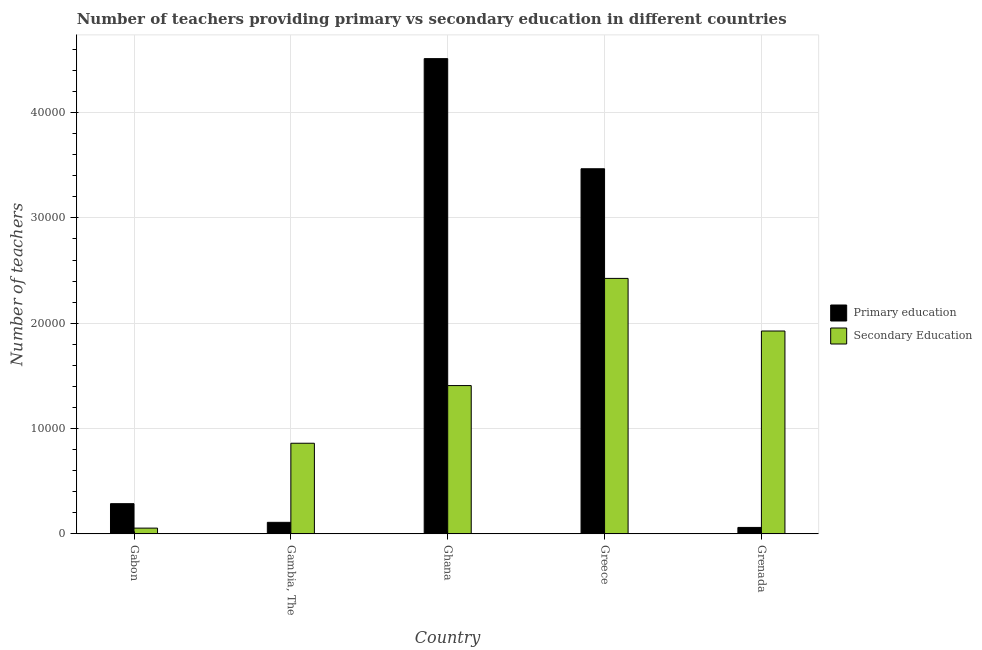How many different coloured bars are there?
Your response must be concise. 2. How many groups of bars are there?
Your answer should be compact. 5. Are the number of bars per tick equal to the number of legend labels?
Give a very brief answer. Yes. How many bars are there on the 2nd tick from the right?
Provide a succinct answer. 2. What is the label of the 1st group of bars from the left?
Provide a short and direct response. Gabon. In how many cases, is the number of bars for a given country not equal to the number of legend labels?
Ensure brevity in your answer.  0. What is the number of secondary teachers in Grenada?
Make the answer very short. 1.93e+04. Across all countries, what is the maximum number of primary teachers?
Ensure brevity in your answer.  4.51e+04. Across all countries, what is the minimum number of primary teachers?
Offer a very short reply. 610. In which country was the number of secondary teachers minimum?
Keep it short and to the point. Gabon. What is the total number of primary teachers in the graph?
Your response must be concise. 8.44e+04. What is the difference between the number of secondary teachers in Gabon and that in Grenada?
Make the answer very short. -1.87e+04. What is the difference between the number of secondary teachers in Gambia, The and the number of primary teachers in Ghana?
Your answer should be very brief. -3.65e+04. What is the average number of primary teachers per country?
Make the answer very short. 1.69e+04. What is the difference between the number of primary teachers and number of secondary teachers in Gabon?
Offer a terse response. 2321. In how many countries, is the number of primary teachers greater than 32000 ?
Your response must be concise. 2. What is the ratio of the number of secondary teachers in Gambia, The to that in Greece?
Offer a very short reply. 0.35. What is the difference between the highest and the second highest number of secondary teachers?
Your answer should be very brief. 4995. What is the difference between the highest and the lowest number of primary teachers?
Provide a short and direct response. 4.45e+04. In how many countries, is the number of secondary teachers greater than the average number of secondary teachers taken over all countries?
Give a very brief answer. 3. What does the 1st bar from the right in Ghana represents?
Keep it short and to the point. Secondary Education. How many countries are there in the graph?
Your answer should be compact. 5. What is the difference between two consecutive major ticks on the Y-axis?
Keep it short and to the point. 10000. Are the values on the major ticks of Y-axis written in scientific E-notation?
Offer a very short reply. No. Where does the legend appear in the graph?
Give a very brief answer. Center right. How are the legend labels stacked?
Offer a terse response. Vertical. What is the title of the graph?
Keep it short and to the point. Number of teachers providing primary vs secondary education in different countries. What is the label or title of the Y-axis?
Ensure brevity in your answer.  Number of teachers. What is the Number of teachers in Primary education in Gabon?
Make the answer very short. 2866. What is the Number of teachers in Secondary Education in Gabon?
Offer a very short reply. 545. What is the Number of teachers in Primary education in Gambia, The?
Your answer should be compact. 1094. What is the Number of teachers in Secondary Education in Gambia, The?
Keep it short and to the point. 8604. What is the Number of teachers in Primary education in Ghana?
Your answer should be compact. 4.51e+04. What is the Number of teachers of Secondary Education in Ghana?
Provide a succinct answer. 1.41e+04. What is the Number of teachers of Primary education in Greece?
Offer a terse response. 3.47e+04. What is the Number of teachers of Secondary Education in Greece?
Give a very brief answer. 2.43e+04. What is the Number of teachers in Primary education in Grenada?
Offer a terse response. 610. What is the Number of teachers of Secondary Education in Grenada?
Make the answer very short. 1.93e+04. Across all countries, what is the maximum Number of teachers in Primary education?
Offer a terse response. 4.51e+04. Across all countries, what is the maximum Number of teachers in Secondary Education?
Provide a succinct answer. 2.43e+04. Across all countries, what is the minimum Number of teachers in Primary education?
Give a very brief answer. 610. Across all countries, what is the minimum Number of teachers of Secondary Education?
Your answer should be very brief. 545. What is the total Number of teachers in Primary education in the graph?
Ensure brevity in your answer.  8.44e+04. What is the total Number of teachers of Secondary Education in the graph?
Your answer should be very brief. 6.67e+04. What is the difference between the Number of teachers in Primary education in Gabon and that in Gambia, The?
Make the answer very short. 1772. What is the difference between the Number of teachers in Secondary Education in Gabon and that in Gambia, The?
Provide a succinct answer. -8059. What is the difference between the Number of teachers of Primary education in Gabon and that in Ghana?
Keep it short and to the point. -4.23e+04. What is the difference between the Number of teachers in Secondary Education in Gabon and that in Ghana?
Keep it short and to the point. -1.35e+04. What is the difference between the Number of teachers in Primary education in Gabon and that in Greece?
Provide a short and direct response. -3.18e+04. What is the difference between the Number of teachers of Secondary Education in Gabon and that in Greece?
Ensure brevity in your answer.  -2.37e+04. What is the difference between the Number of teachers of Primary education in Gabon and that in Grenada?
Make the answer very short. 2256. What is the difference between the Number of teachers in Secondary Education in Gabon and that in Grenada?
Keep it short and to the point. -1.87e+04. What is the difference between the Number of teachers of Primary education in Gambia, The and that in Ghana?
Offer a terse response. -4.40e+04. What is the difference between the Number of teachers in Secondary Education in Gambia, The and that in Ghana?
Your response must be concise. -5475. What is the difference between the Number of teachers of Primary education in Gambia, The and that in Greece?
Give a very brief answer. -3.36e+04. What is the difference between the Number of teachers in Secondary Education in Gambia, The and that in Greece?
Your answer should be very brief. -1.57e+04. What is the difference between the Number of teachers of Primary education in Gambia, The and that in Grenada?
Offer a terse response. 484. What is the difference between the Number of teachers in Secondary Education in Gambia, The and that in Grenada?
Offer a terse response. -1.07e+04. What is the difference between the Number of teachers of Primary education in Ghana and that in Greece?
Give a very brief answer. 1.05e+04. What is the difference between the Number of teachers in Secondary Education in Ghana and that in Greece?
Keep it short and to the point. -1.02e+04. What is the difference between the Number of teachers in Primary education in Ghana and that in Grenada?
Ensure brevity in your answer.  4.45e+04. What is the difference between the Number of teachers of Secondary Education in Ghana and that in Grenada?
Your response must be concise. -5181. What is the difference between the Number of teachers in Primary education in Greece and that in Grenada?
Ensure brevity in your answer.  3.41e+04. What is the difference between the Number of teachers of Secondary Education in Greece and that in Grenada?
Offer a terse response. 4995. What is the difference between the Number of teachers of Primary education in Gabon and the Number of teachers of Secondary Education in Gambia, The?
Offer a very short reply. -5738. What is the difference between the Number of teachers of Primary education in Gabon and the Number of teachers of Secondary Education in Ghana?
Give a very brief answer. -1.12e+04. What is the difference between the Number of teachers of Primary education in Gabon and the Number of teachers of Secondary Education in Greece?
Provide a short and direct response. -2.14e+04. What is the difference between the Number of teachers in Primary education in Gabon and the Number of teachers in Secondary Education in Grenada?
Offer a very short reply. -1.64e+04. What is the difference between the Number of teachers in Primary education in Gambia, The and the Number of teachers in Secondary Education in Ghana?
Your response must be concise. -1.30e+04. What is the difference between the Number of teachers in Primary education in Gambia, The and the Number of teachers in Secondary Education in Greece?
Your answer should be compact. -2.32e+04. What is the difference between the Number of teachers in Primary education in Gambia, The and the Number of teachers in Secondary Education in Grenada?
Give a very brief answer. -1.82e+04. What is the difference between the Number of teachers of Primary education in Ghana and the Number of teachers of Secondary Education in Greece?
Provide a short and direct response. 2.09e+04. What is the difference between the Number of teachers in Primary education in Ghana and the Number of teachers in Secondary Education in Grenada?
Provide a succinct answer. 2.59e+04. What is the difference between the Number of teachers in Primary education in Greece and the Number of teachers in Secondary Education in Grenada?
Your answer should be compact. 1.54e+04. What is the average Number of teachers in Primary education per country?
Keep it short and to the point. 1.69e+04. What is the average Number of teachers in Secondary Education per country?
Ensure brevity in your answer.  1.33e+04. What is the difference between the Number of teachers of Primary education and Number of teachers of Secondary Education in Gabon?
Offer a very short reply. 2321. What is the difference between the Number of teachers in Primary education and Number of teachers in Secondary Education in Gambia, The?
Your response must be concise. -7510. What is the difference between the Number of teachers of Primary education and Number of teachers of Secondary Education in Ghana?
Offer a terse response. 3.10e+04. What is the difference between the Number of teachers of Primary education and Number of teachers of Secondary Education in Greece?
Your answer should be very brief. 1.04e+04. What is the difference between the Number of teachers of Primary education and Number of teachers of Secondary Education in Grenada?
Make the answer very short. -1.86e+04. What is the ratio of the Number of teachers of Primary education in Gabon to that in Gambia, The?
Your response must be concise. 2.62. What is the ratio of the Number of teachers of Secondary Education in Gabon to that in Gambia, The?
Make the answer very short. 0.06. What is the ratio of the Number of teachers in Primary education in Gabon to that in Ghana?
Give a very brief answer. 0.06. What is the ratio of the Number of teachers in Secondary Education in Gabon to that in Ghana?
Your response must be concise. 0.04. What is the ratio of the Number of teachers in Primary education in Gabon to that in Greece?
Your response must be concise. 0.08. What is the ratio of the Number of teachers in Secondary Education in Gabon to that in Greece?
Provide a succinct answer. 0.02. What is the ratio of the Number of teachers of Primary education in Gabon to that in Grenada?
Give a very brief answer. 4.7. What is the ratio of the Number of teachers of Secondary Education in Gabon to that in Grenada?
Ensure brevity in your answer.  0.03. What is the ratio of the Number of teachers in Primary education in Gambia, The to that in Ghana?
Ensure brevity in your answer.  0.02. What is the ratio of the Number of teachers of Secondary Education in Gambia, The to that in Ghana?
Your answer should be compact. 0.61. What is the ratio of the Number of teachers in Primary education in Gambia, The to that in Greece?
Your answer should be very brief. 0.03. What is the ratio of the Number of teachers of Secondary Education in Gambia, The to that in Greece?
Provide a succinct answer. 0.35. What is the ratio of the Number of teachers of Primary education in Gambia, The to that in Grenada?
Keep it short and to the point. 1.79. What is the ratio of the Number of teachers of Secondary Education in Gambia, The to that in Grenada?
Offer a terse response. 0.45. What is the ratio of the Number of teachers of Primary education in Ghana to that in Greece?
Your answer should be compact. 1.3. What is the ratio of the Number of teachers of Secondary Education in Ghana to that in Greece?
Provide a succinct answer. 0.58. What is the ratio of the Number of teachers of Primary education in Ghana to that in Grenada?
Your response must be concise. 73.97. What is the ratio of the Number of teachers of Secondary Education in Ghana to that in Grenada?
Make the answer very short. 0.73. What is the ratio of the Number of teachers in Primary education in Greece to that in Grenada?
Your answer should be very brief. 56.83. What is the ratio of the Number of teachers in Secondary Education in Greece to that in Grenada?
Your answer should be very brief. 1.26. What is the difference between the highest and the second highest Number of teachers in Primary education?
Your answer should be very brief. 1.05e+04. What is the difference between the highest and the second highest Number of teachers of Secondary Education?
Your response must be concise. 4995. What is the difference between the highest and the lowest Number of teachers of Primary education?
Ensure brevity in your answer.  4.45e+04. What is the difference between the highest and the lowest Number of teachers in Secondary Education?
Your answer should be very brief. 2.37e+04. 